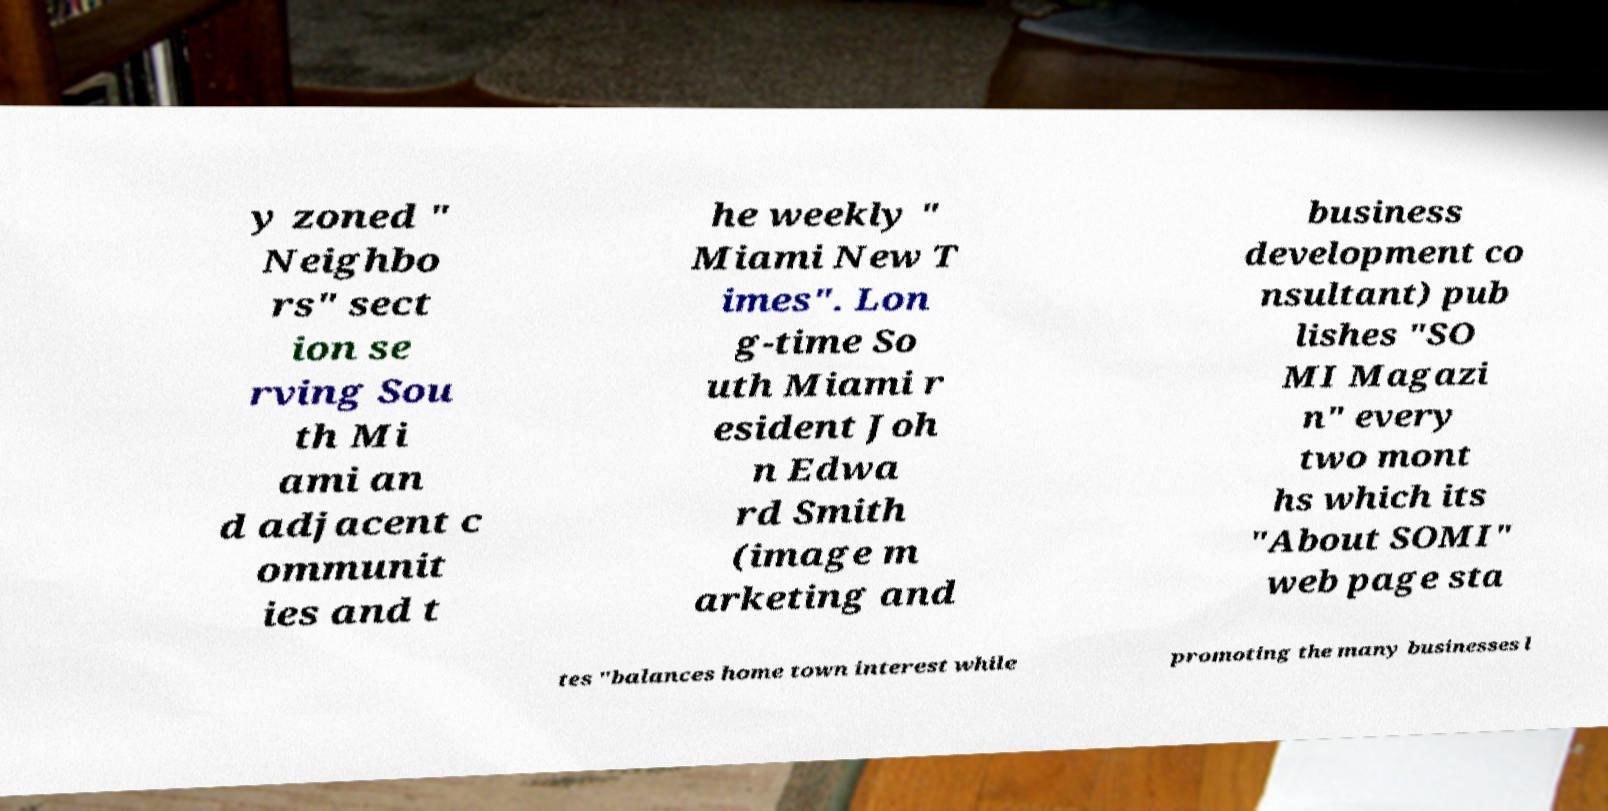Could you extract and type out the text from this image? y zoned " Neighbo rs" sect ion se rving Sou th Mi ami an d adjacent c ommunit ies and t he weekly " Miami New T imes". Lon g-time So uth Miami r esident Joh n Edwa rd Smith (image m arketing and business development co nsultant) pub lishes "SO MI Magazi n" every two mont hs which its "About SOMI" web page sta tes "balances home town interest while promoting the many businesses l 